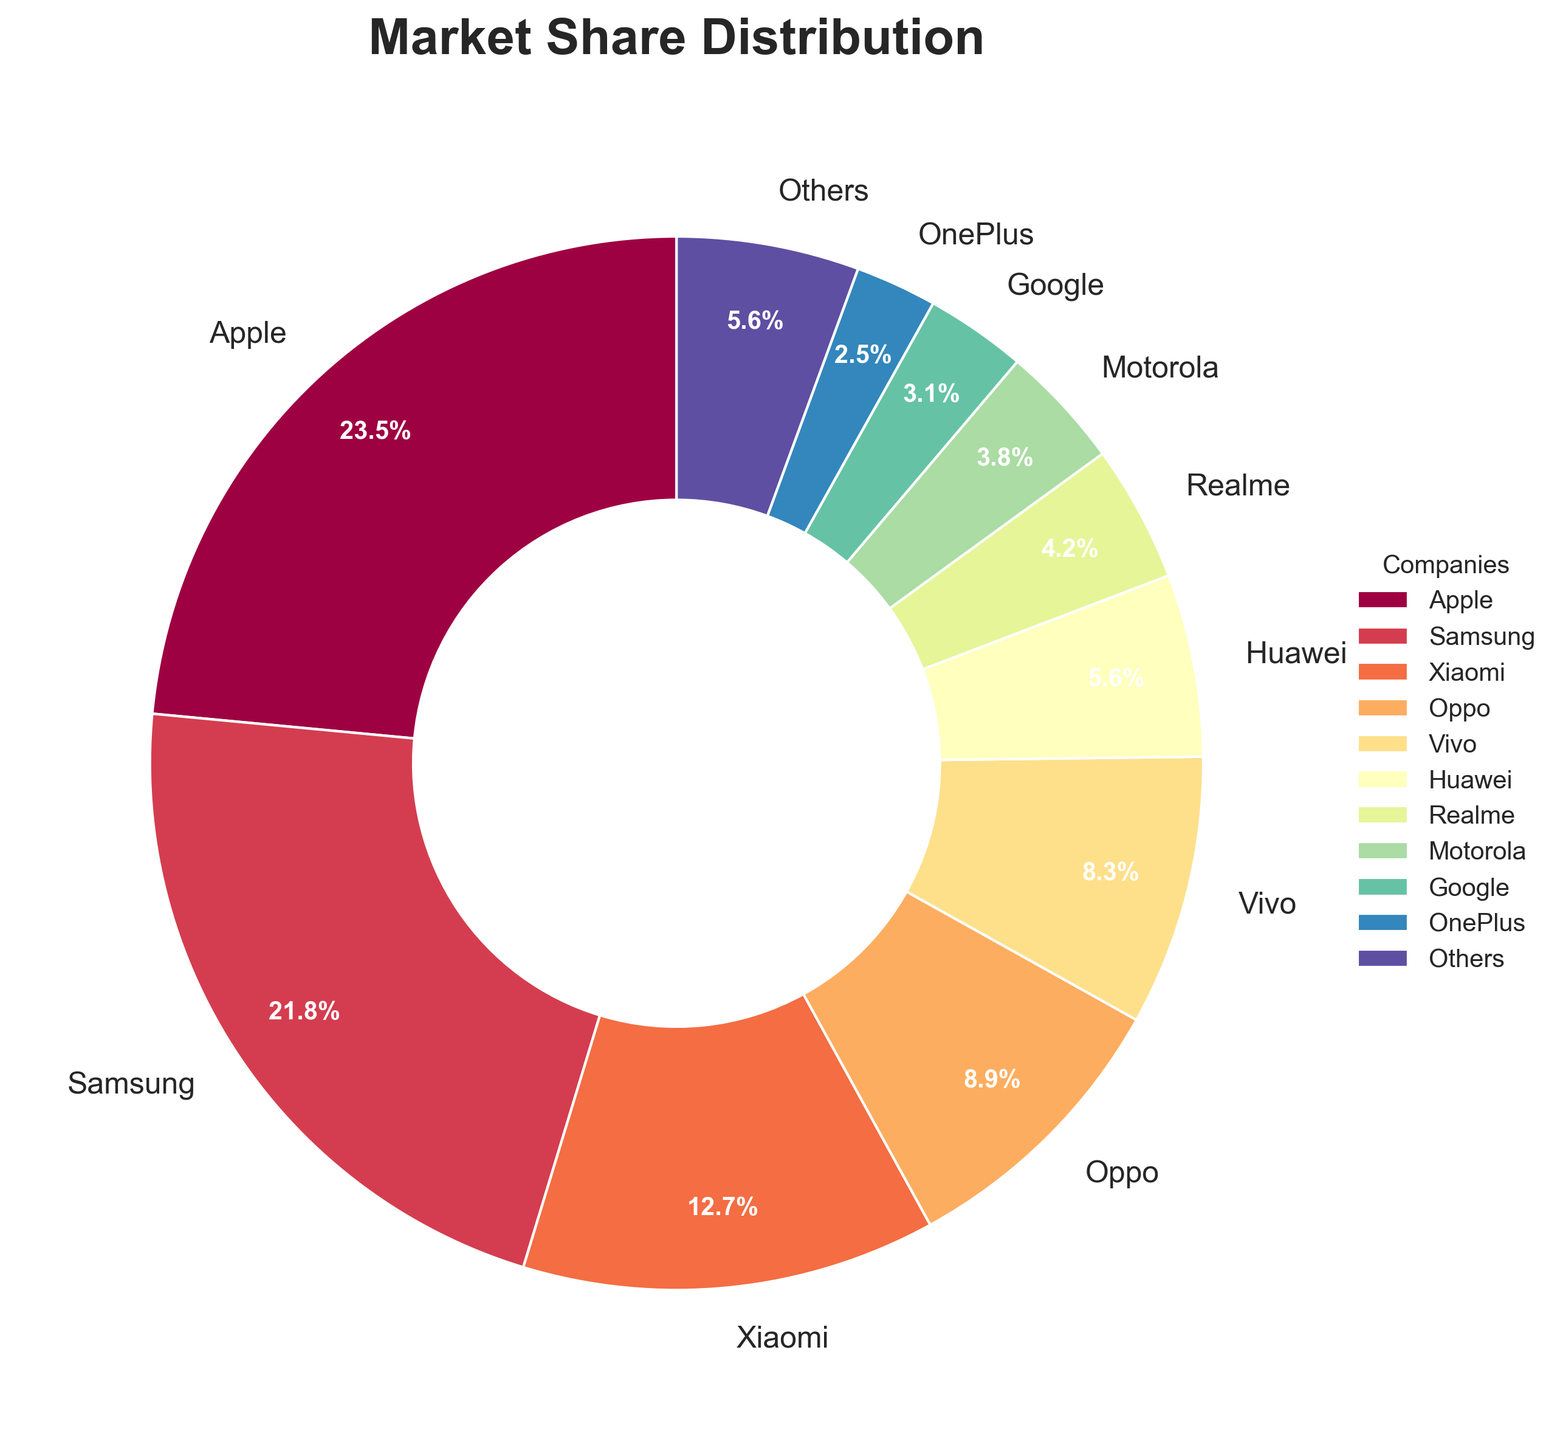Which company has the largest market share? By looking at the pie chart, we can see that Apple has the largest wedge, indicating the highest market share.
Answer: Apple What is the combined market share of Vivo and Oppo? According to the chart, Vivo has a market share of 8.3% and Oppo has a market share of 8.9%. Adding these together, 8.3% + 8.9% = 17.2%.
Answer: 17.2% How does Realme's market share compare with Motorola's? From the figure, Realme has a market share of 4.2% while Motorola has 3.8%. Realme’s market share is slightly higher than Motorola’s.
Answer: Realme's market share is higher Which companies have less than a 5% market share? Based on the pie chart, the companies with less than a 5% market share are Realme (4.2%), Motorola (3.8%), Google (3.1%), and OnePlus (2.5%).
Answer: Realme, Motorola, Google, OnePlus What is the combined market share of the top three companies? The top three companies by market share are Apple (23.5%), Samsung (21.8%), and Xiaomi (12.7%). Adding these together, 23.5% + 21.8% + 12.7% = 58%.
Answer: 58% Which company's market share is equal to the sum of Google and OnePlus' market shares? Google's market share is 3.1% and OnePlus' market share is 2.5%, so their sum is 3.1% + 2.5% = 5.6%. Huawei has a market share of 5.6%, which is the same as the sum of Google and OnePlus' market shares.
Answer: Huawei Compare the combined market share of the top 5 companies to the remaining companies. The top five companies are Apple, Samsung, Xiaomi, Oppo, and Vivo. Their combined market share is 23.5% + 21.8% + 12.7% + 8.9% + 8.3% = 75.2%. The remaining companies' market share is 100% - 75.2% = 24.8%.
Answer: The top 5 companies' combined share is 75.2%, and the remaining companies' combined share is 24.8% Is there any company with a market share exactly equal to the "Others" category? The pie chart shows that both Huawei and "Others" have a market share of 5.6%.
Answer: Huawei Which company is represented by the smallest wedge in the pie chart? The smallest wedge in the pie chart represents OnePlus, which has a market share of 2.5%.
Answer: OnePlus 